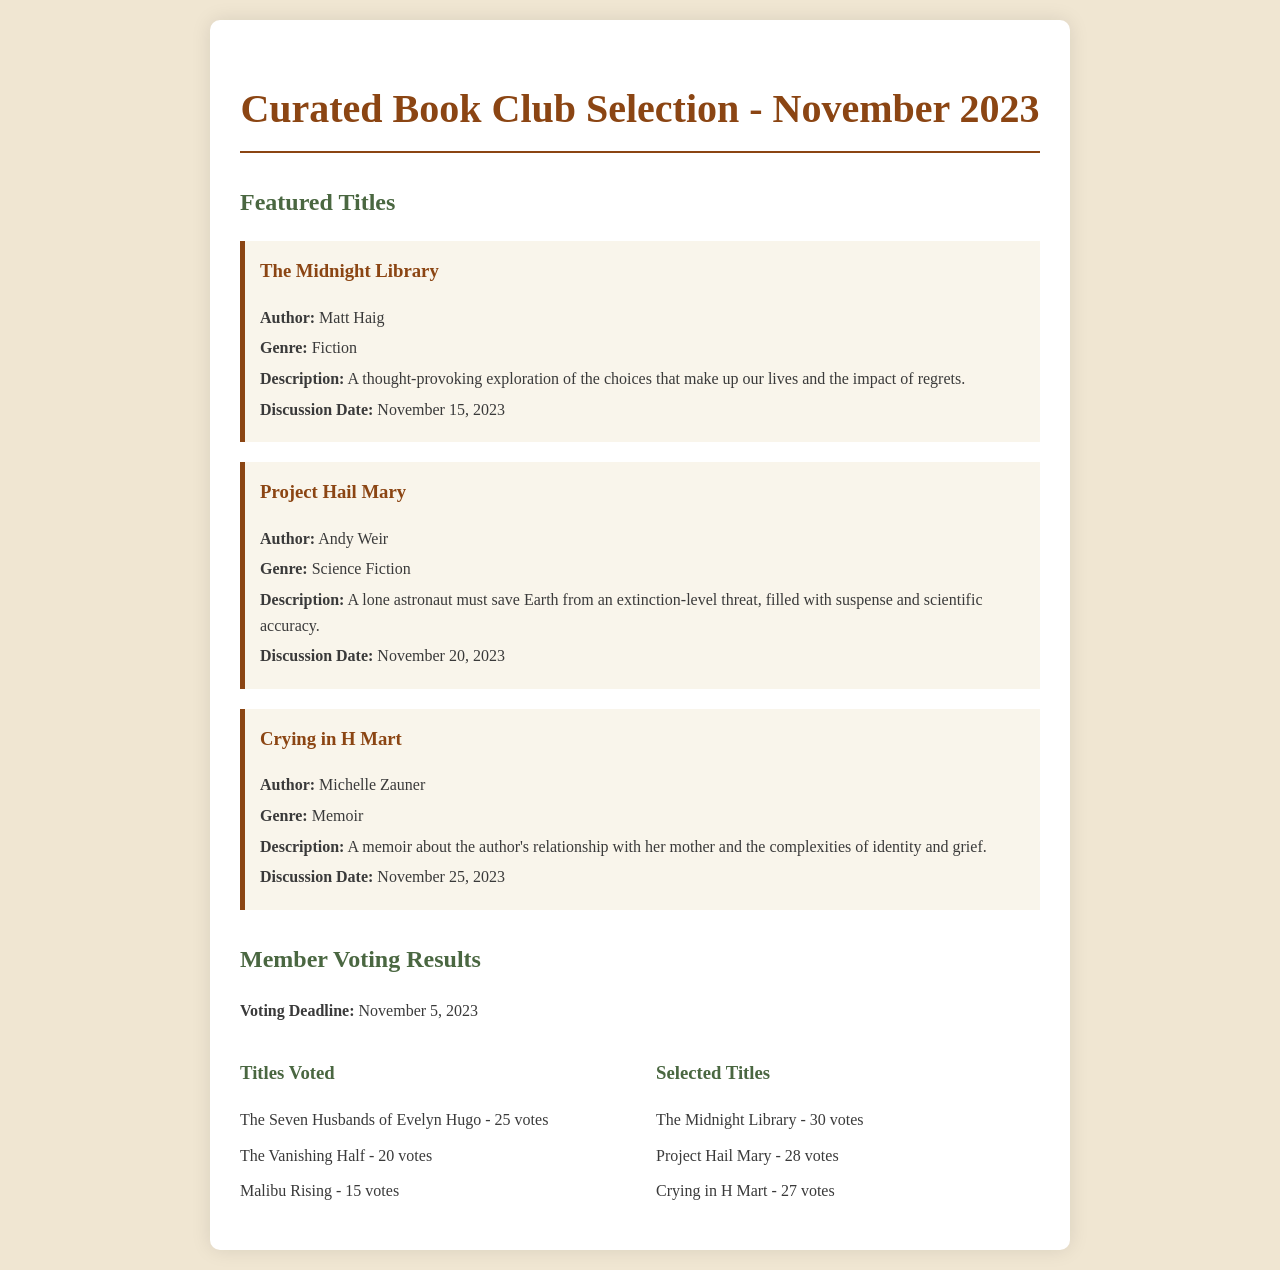What is the title of the first featured book? The title of the first featured book is listed in the document under the Featured Titles section.
Answer: The Midnight Library Who is the author of "Project Hail Mary"? The author of "Project Hail Mary" is provided in the book information section.
Answer: Andy Weir What genre is "Crying in H Mart"? The genre of "Crying in H Mart" is specified in the document under the book description.
Answer: Memoir What is the discussion date for "The Midnight Library"? The discussion date for "The Midnight Library" is mentioned in the document and time periods are indicated for each book.
Answer: November 15, 2023 How many votes did "The Midnight Library" receive? The number of votes is provided in the Member Voting Results section, specifically under Selected Titles.
Answer: 30 votes Which title received the second most votes? The title with the second most votes is indicated in the Selected Titles list.
Answer: Project Hail Mary What is the voting deadline date? The voting deadline is stated explicitly in the document regarding the member voting results.
Answer: November 5, 2023 How many titles were voted on in total? The total number of titles is reflected by the count of the Titles Voted section and the Selected Titles section.
Answer: 6 titles 